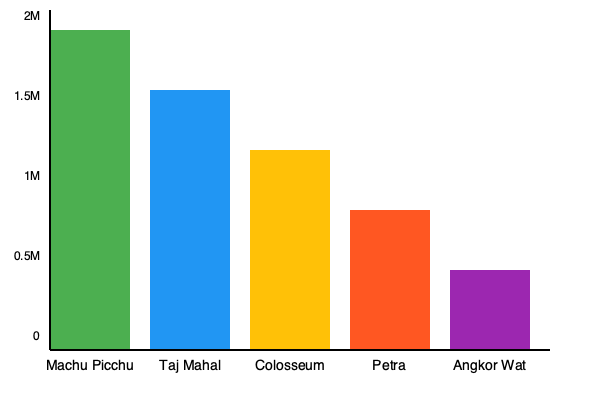Based on the bar graph showing visitor statistics for top World Heritage sites, what is the approximate difference in annual visitors (in millions) between Machu Picchu and Petra? To find the difference in annual visitors between Machu Picchu and Petra, we need to:

1. Estimate the number of visitors for Machu Picchu:
   - The bar reaches almost to the top of the graph (2M mark)
   - Estimate: approximately 1.8 million visitors

2. Estimate the number of visitors for Petra:
   - The bar reaches slightly below the 1M mark
   - Estimate: approximately 0.8 million visitors

3. Calculate the difference:
   $1.8 \text{ million} - 0.8 \text{ million} = 1 \text{ million}$

Therefore, the approximate difference in annual visitors between Machu Picchu and Petra is 1 million.
Answer: 1 million 